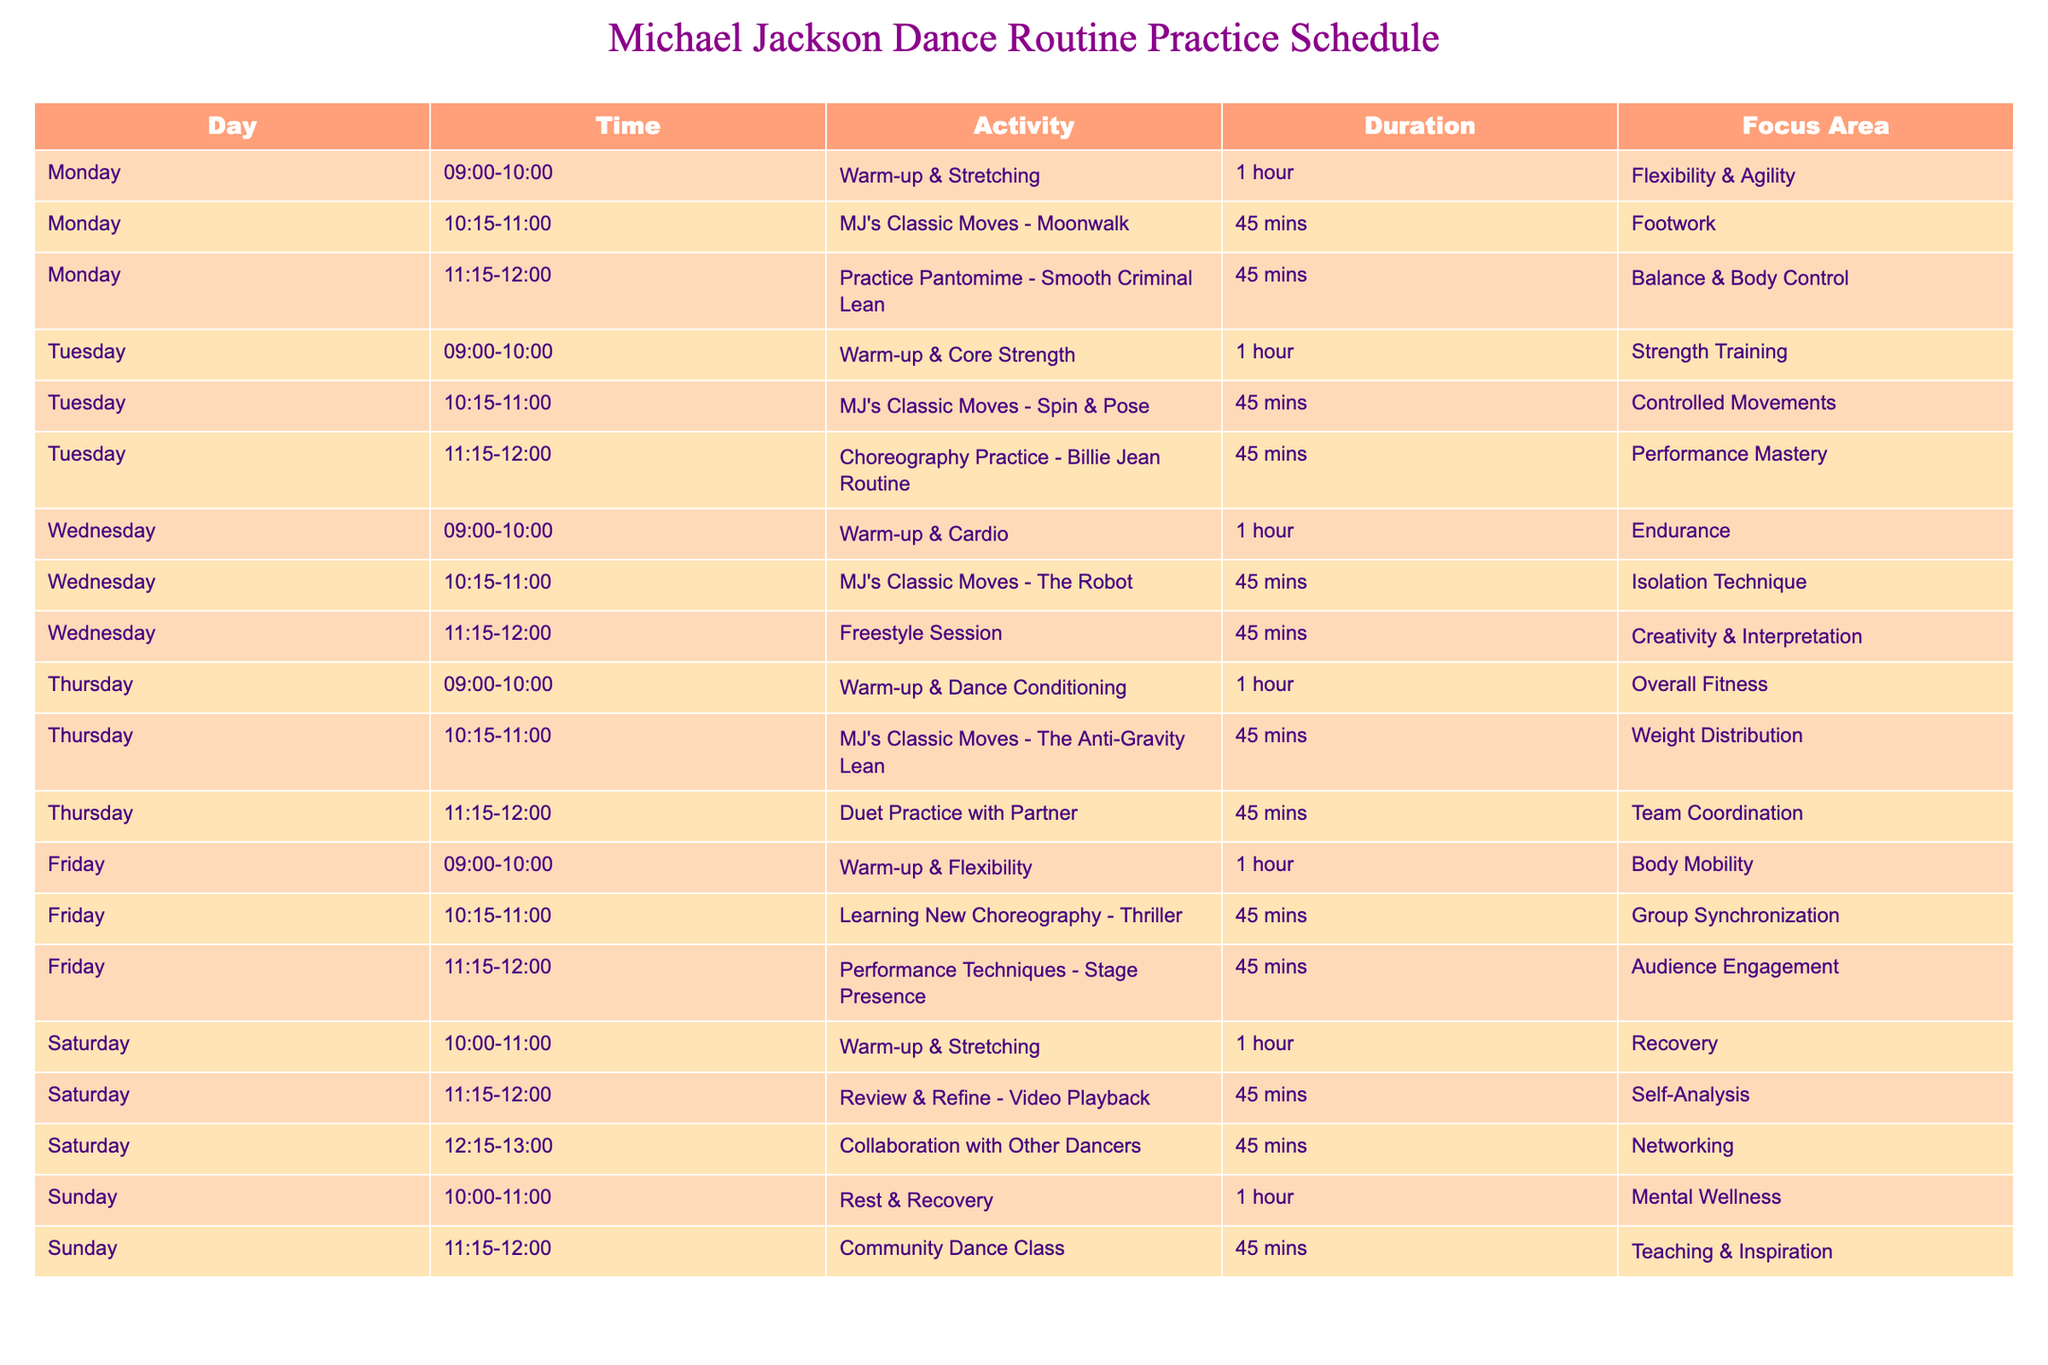What activity is scheduled on Monday at 11:15 AM? The table shows that on Monday at 11:15 AM, the activity is "Practice Pantomime - Smooth Criminal Lean," which focuses on balance and body control.
Answer: Practice Pantomime - Smooth Criminal Lean What is the total duration of activities scheduled on Wednesday? On Wednesday, there are three activities: "Warm-up & Cardio" for 1 hour, "MJ's Classic Moves - The Robot" for 45 minutes, and "Freestyle Session" for 45 minutes. The total duration is 1 hour + 45 minutes + 45 minutes = 2 hours and 30 minutes.
Answer: 2 hours and 30 minutes Is there a scheduled activity for group synchronization before the weekend? The table indicates that there is an activity for "Learning New Choreography - Thriller" on Friday, focused on group synchronization. Since it falls on a Friday, it is indeed scheduled before the weekend.
Answer: Yes What are the focus areas of activities on Tuesday? On Tuesday, the focus areas for the activities are as follows: "Warm-up & Core Strength" focuses on strength training; "MJ's Classic Moves - Spin & Pose" focuses on controlled movements; and "Choreography Practice - Billie Jean Routine" focuses on performance mastery.
Answer: Strength training, controlled movements, performance mastery How does the total duration of activities on Saturday compare to that of Friday? On Saturday, there are three activities: "Warm-up & Stretching" for 1 hour, "Review & Refine - Video Playback" for 45 minutes, and "Collaboration with Other Dancers" for 45 minutes, totaling 2 hours and 30 minutes (1 hour + 45 minutes + 45 minutes). On Friday, the total duration of activities is also 2 hours and 30 minutes (1 hour + 45 minutes + 45 minutes). Hence, both days have the same total duration of activities.
Answer: They are equal 